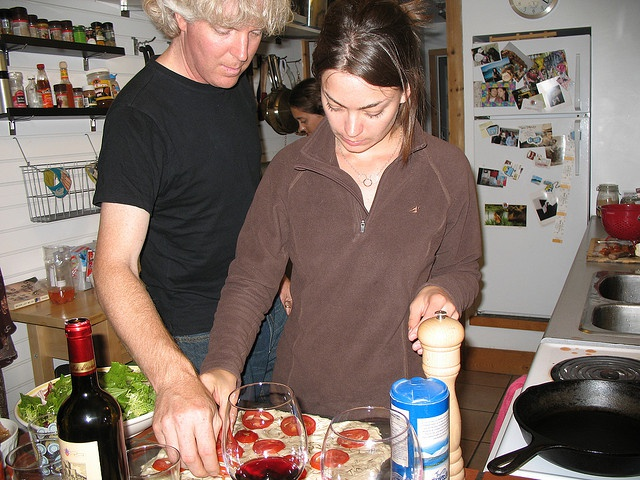Describe the objects in this image and their specific colors. I can see people in gray, brown, black, and tan tones, people in gray, black, tan, and lightgray tones, refrigerator in gray, darkgray, black, and lightgray tones, wine glass in gray, black, brown, tan, and maroon tones, and oven in gray, lightgray, black, and darkgray tones in this image. 